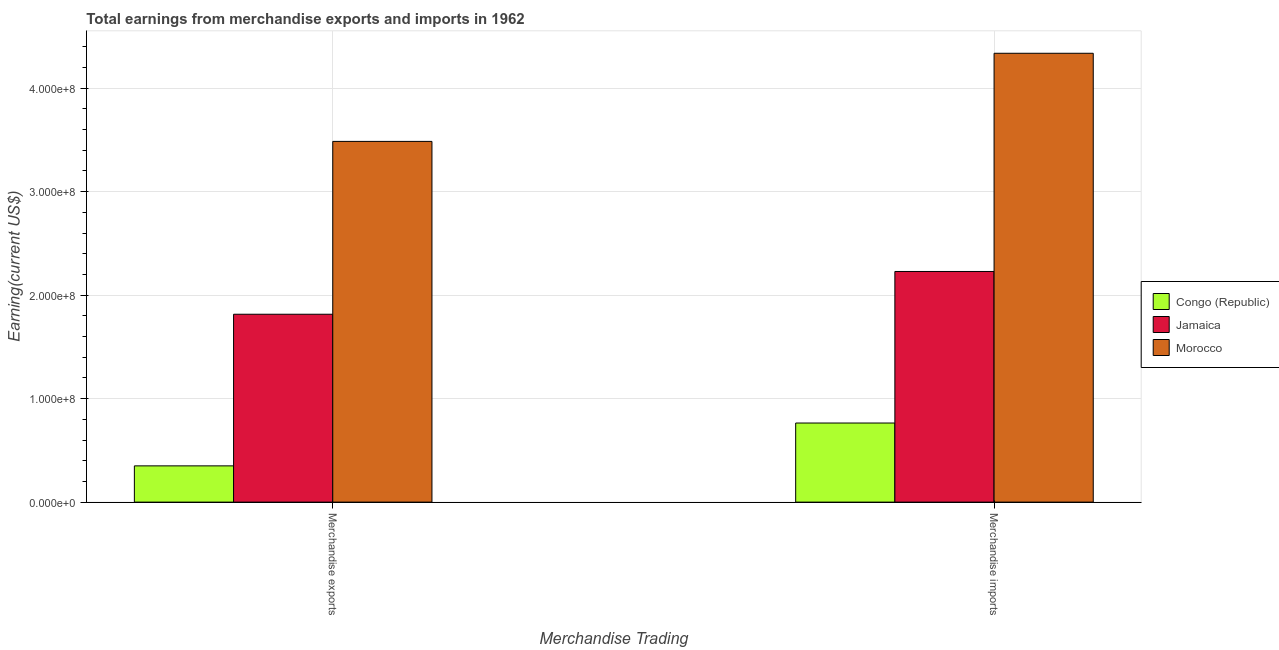How many different coloured bars are there?
Make the answer very short. 3. How many groups of bars are there?
Offer a terse response. 2. Are the number of bars per tick equal to the number of legend labels?
Provide a short and direct response. Yes. What is the earnings from merchandise imports in Jamaica?
Provide a short and direct response. 2.23e+08. Across all countries, what is the maximum earnings from merchandise exports?
Provide a succinct answer. 3.49e+08. Across all countries, what is the minimum earnings from merchandise imports?
Your answer should be compact. 7.64e+07. In which country was the earnings from merchandise exports maximum?
Keep it short and to the point. Morocco. In which country was the earnings from merchandise imports minimum?
Provide a short and direct response. Congo (Republic). What is the total earnings from merchandise exports in the graph?
Give a very brief answer. 5.65e+08. What is the difference between the earnings from merchandise imports in Jamaica and that in Congo (Republic)?
Your response must be concise. 1.46e+08. What is the difference between the earnings from merchandise exports in Morocco and the earnings from merchandise imports in Jamaica?
Provide a succinct answer. 1.26e+08. What is the average earnings from merchandise imports per country?
Offer a terse response. 2.44e+08. What is the difference between the earnings from merchandise imports and earnings from merchandise exports in Congo (Republic)?
Offer a terse response. 4.14e+07. In how many countries, is the earnings from merchandise imports greater than 260000000 US$?
Make the answer very short. 1. What is the ratio of the earnings from merchandise imports in Morocco to that in Jamaica?
Give a very brief answer. 1.95. What does the 2nd bar from the left in Merchandise imports represents?
Offer a very short reply. Jamaica. What does the 1st bar from the right in Merchandise exports represents?
Keep it short and to the point. Morocco. How many bars are there?
Keep it short and to the point. 6. Does the graph contain any zero values?
Keep it short and to the point. No. What is the title of the graph?
Your response must be concise. Total earnings from merchandise exports and imports in 1962. Does "Sri Lanka" appear as one of the legend labels in the graph?
Offer a terse response. No. What is the label or title of the X-axis?
Offer a very short reply. Merchandise Trading. What is the label or title of the Y-axis?
Provide a succinct answer. Earning(current US$). What is the Earning(current US$) in Congo (Republic) in Merchandise exports?
Ensure brevity in your answer.  3.50e+07. What is the Earning(current US$) in Jamaica in Merchandise exports?
Provide a succinct answer. 1.82e+08. What is the Earning(current US$) in Morocco in Merchandise exports?
Offer a very short reply. 3.49e+08. What is the Earning(current US$) in Congo (Republic) in Merchandise imports?
Offer a very short reply. 7.64e+07. What is the Earning(current US$) of Jamaica in Merchandise imports?
Ensure brevity in your answer.  2.23e+08. What is the Earning(current US$) in Morocco in Merchandise imports?
Your answer should be compact. 4.34e+08. Across all Merchandise Trading, what is the maximum Earning(current US$) in Congo (Republic)?
Provide a short and direct response. 7.64e+07. Across all Merchandise Trading, what is the maximum Earning(current US$) of Jamaica?
Your answer should be compact. 2.23e+08. Across all Merchandise Trading, what is the maximum Earning(current US$) of Morocco?
Your response must be concise. 4.34e+08. Across all Merchandise Trading, what is the minimum Earning(current US$) in Congo (Republic)?
Offer a terse response. 3.50e+07. Across all Merchandise Trading, what is the minimum Earning(current US$) of Jamaica?
Your response must be concise. 1.82e+08. Across all Merchandise Trading, what is the minimum Earning(current US$) in Morocco?
Offer a very short reply. 3.49e+08. What is the total Earning(current US$) in Congo (Republic) in the graph?
Your answer should be very brief. 1.11e+08. What is the total Earning(current US$) in Jamaica in the graph?
Provide a short and direct response. 4.04e+08. What is the total Earning(current US$) in Morocco in the graph?
Provide a short and direct response. 7.82e+08. What is the difference between the Earning(current US$) in Congo (Republic) in Merchandise exports and that in Merchandise imports?
Give a very brief answer. -4.14e+07. What is the difference between the Earning(current US$) in Jamaica in Merchandise exports and that in Merchandise imports?
Your answer should be very brief. -4.13e+07. What is the difference between the Earning(current US$) of Morocco in Merchandise exports and that in Merchandise imports?
Provide a succinct answer. -8.52e+07. What is the difference between the Earning(current US$) of Congo (Republic) in Merchandise exports and the Earning(current US$) of Jamaica in Merchandise imports?
Offer a very short reply. -1.88e+08. What is the difference between the Earning(current US$) in Congo (Republic) in Merchandise exports and the Earning(current US$) in Morocco in Merchandise imports?
Your response must be concise. -3.99e+08. What is the difference between the Earning(current US$) of Jamaica in Merchandise exports and the Earning(current US$) of Morocco in Merchandise imports?
Make the answer very short. -2.52e+08. What is the average Earning(current US$) of Congo (Republic) per Merchandise Trading?
Keep it short and to the point. 5.57e+07. What is the average Earning(current US$) of Jamaica per Merchandise Trading?
Offer a very short reply. 2.02e+08. What is the average Earning(current US$) of Morocco per Merchandise Trading?
Your answer should be very brief. 3.91e+08. What is the difference between the Earning(current US$) of Congo (Republic) and Earning(current US$) of Jamaica in Merchandise exports?
Your answer should be compact. -1.47e+08. What is the difference between the Earning(current US$) in Congo (Republic) and Earning(current US$) in Morocco in Merchandise exports?
Provide a short and direct response. -3.14e+08. What is the difference between the Earning(current US$) in Jamaica and Earning(current US$) in Morocco in Merchandise exports?
Offer a terse response. -1.67e+08. What is the difference between the Earning(current US$) in Congo (Republic) and Earning(current US$) in Jamaica in Merchandise imports?
Make the answer very short. -1.46e+08. What is the difference between the Earning(current US$) of Congo (Republic) and Earning(current US$) of Morocco in Merchandise imports?
Provide a short and direct response. -3.57e+08. What is the difference between the Earning(current US$) in Jamaica and Earning(current US$) in Morocco in Merchandise imports?
Your answer should be very brief. -2.11e+08. What is the ratio of the Earning(current US$) of Congo (Republic) in Merchandise exports to that in Merchandise imports?
Provide a short and direct response. 0.46. What is the ratio of the Earning(current US$) of Jamaica in Merchandise exports to that in Merchandise imports?
Offer a terse response. 0.81. What is the ratio of the Earning(current US$) of Morocco in Merchandise exports to that in Merchandise imports?
Ensure brevity in your answer.  0.8. What is the difference between the highest and the second highest Earning(current US$) in Congo (Republic)?
Give a very brief answer. 4.14e+07. What is the difference between the highest and the second highest Earning(current US$) of Jamaica?
Provide a short and direct response. 4.13e+07. What is the difference between the highest and the second highest Earning(current US$) of Morocco?
Provide a short and direct response. 8.52e+07. What is the difference between the highest and the lowest Earning(current US$) in Congo (Republic)?
Provide a succinct answer. 4.14e+07. What is the difference between the highest and the lowest Earning(current US$) in Jamaica?
Provide a short and direct response. 4.13e+07. What is the difference between the highest and the lowest Earning(current US$) in Morocco?
Keep it short and to the point. 8.52e+07. 